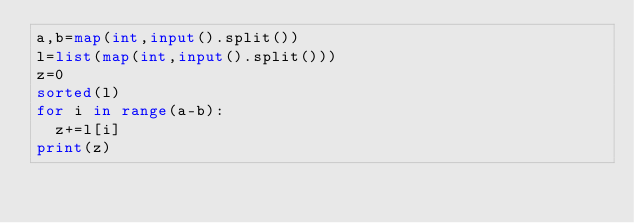<code> <loc_0><loc_0><loc_500><loc_500><_Python_>a,b=map(int,input().split())
l=list(map(int,input().split()))
z=0
sorted(l)
for i in range(a-b):
  z+=l[i]
print(z)</code> 